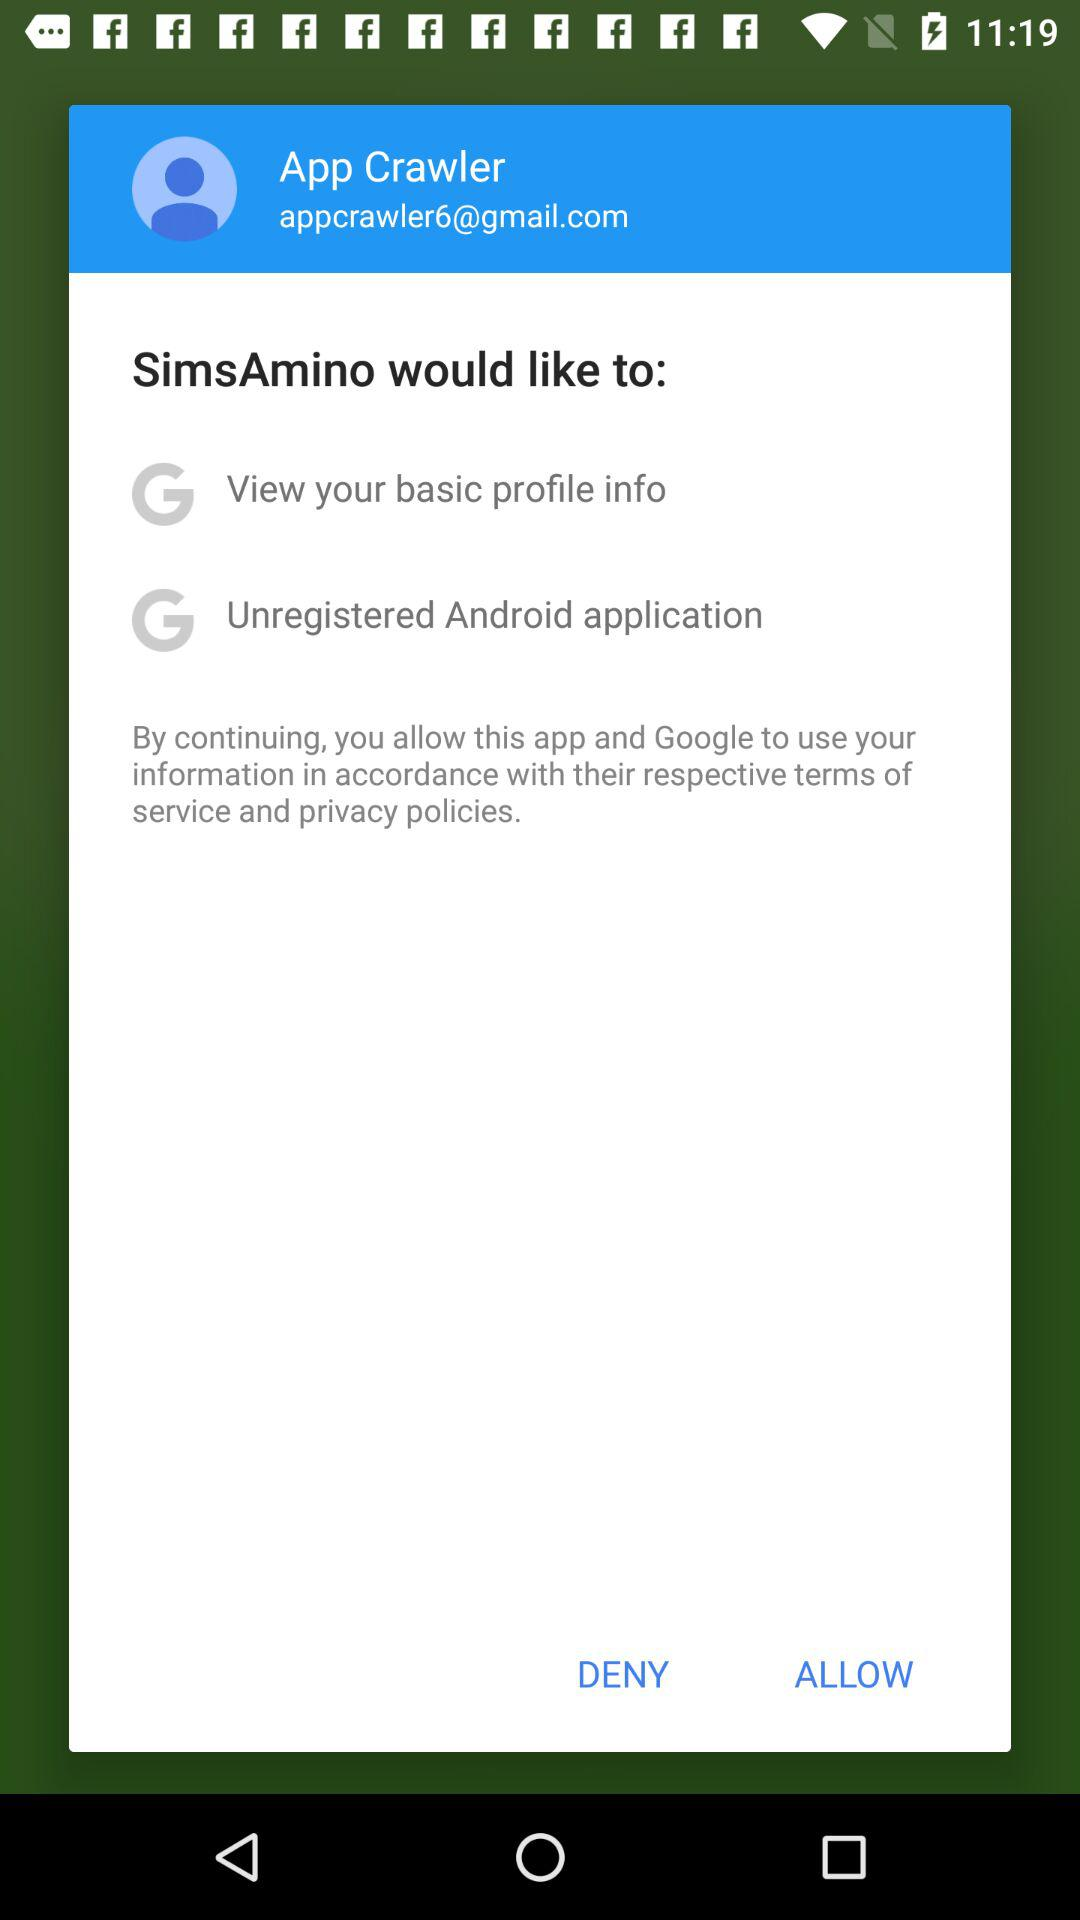What email ID have I logged in from? You have logged in from appcrawler6@gmail.com. 